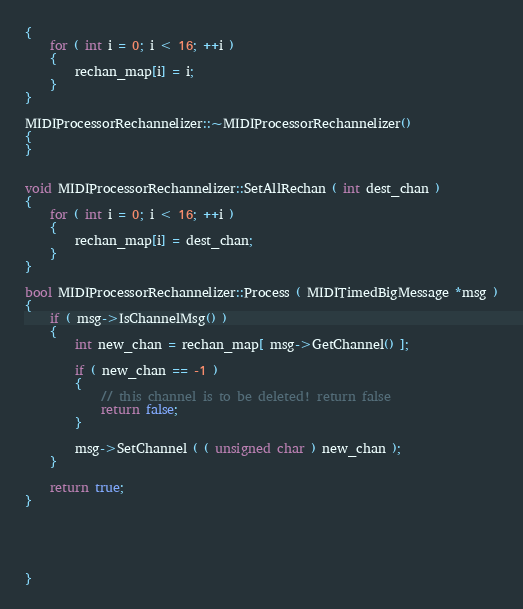<code> <loc_0><loc_0><loc_500><loc_500><_C++_>{
    for ( int i = 0; i < 16; ++i )
    {
        rechan_map[i] = i;
    }
}

MIDIProcessorRechannelizer::~MIDIProcessorRechannelizer()
{
}


void MIDIProcessorRechannelizer::SetAllRechan ( int dest_chan )
{
    for ( int i = 0; i < 16; ++i )
    {
        rechan_map[i] = dest_chan;
    }
}

bool MIDIProcessorRechannelizer::Process ( MIDITimedBigMessage *msg )
{
    if ( msg->IsChannelMsg() )
    {
        int new_chan = rechan_map[ msg->GetChannel() ];

        if ( new_chan == -1 )
        {
            // this channel is to be deleted! return false
            return false;
        }

        msg->SetChannel ( ( unsigned char ) new_chan );
    }

    return true;
}





}
</code> 